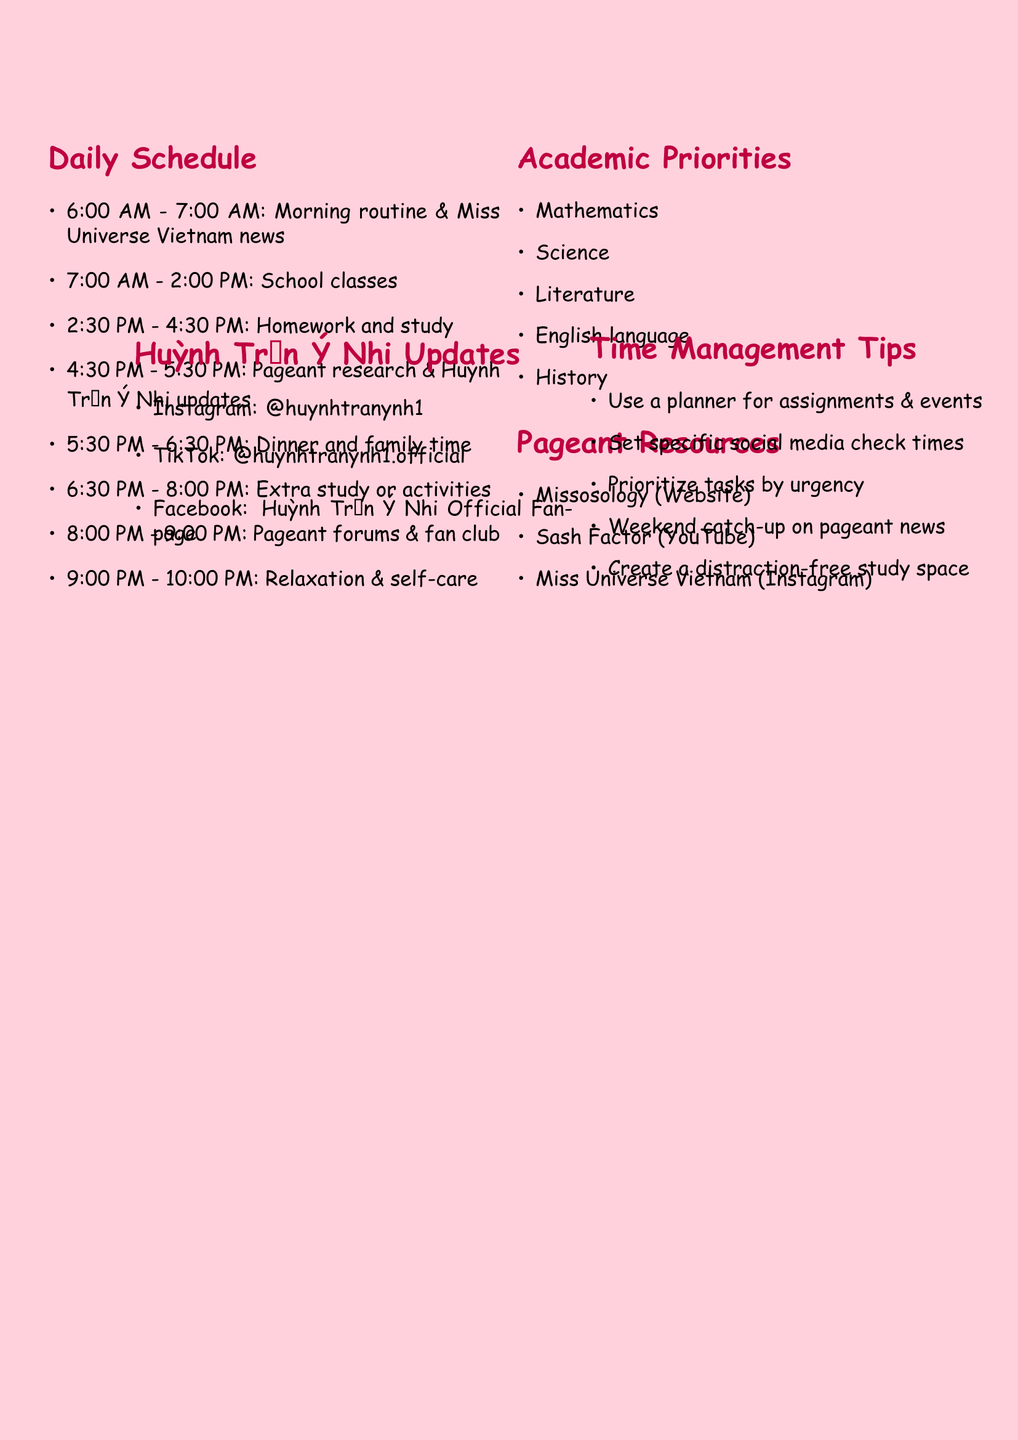what time is the beauty pageant research scheduled? The schedule states beauty pageant research is from 4:30 PM to 5:30 PM.
Answer: 4:30 PM - 5:30 PM how many hours are allocated for relaxation and self-care? The schedule includes one hour for relaxation and self-care from 9:00 PM to 10:00 PM.
Answer: 1 hour what is the focus of the website Missosology? Missosology focuses on international pageant news and analysis.
Answer: International pageant news and analysis which subject is listed last in academic priorities? The last subject listed in the academic priorities is History.
Answer: History what platform is used for daily life updates of Huỳnh Trần Ý Nhi? Instagram is used for daily life updates.
Answer: Instagram how many time management tips are provided? There are five time management tips listed in the document.
Answer: 5 what activity follows family time in the daily schedule? Additional study time or extracurricular activities follows family time.
Answer: Additional study time or extracurricular activities which social media platform has the handle @huynhtranynh1? The handle @huynhtranynh1 is used on Instagram.
Answer: Instagram what is a suggested way to incorporate pageant knowledge into studies? The document suggests incorporating pageant knowledge into school projects when possible.
Answer: School projects 